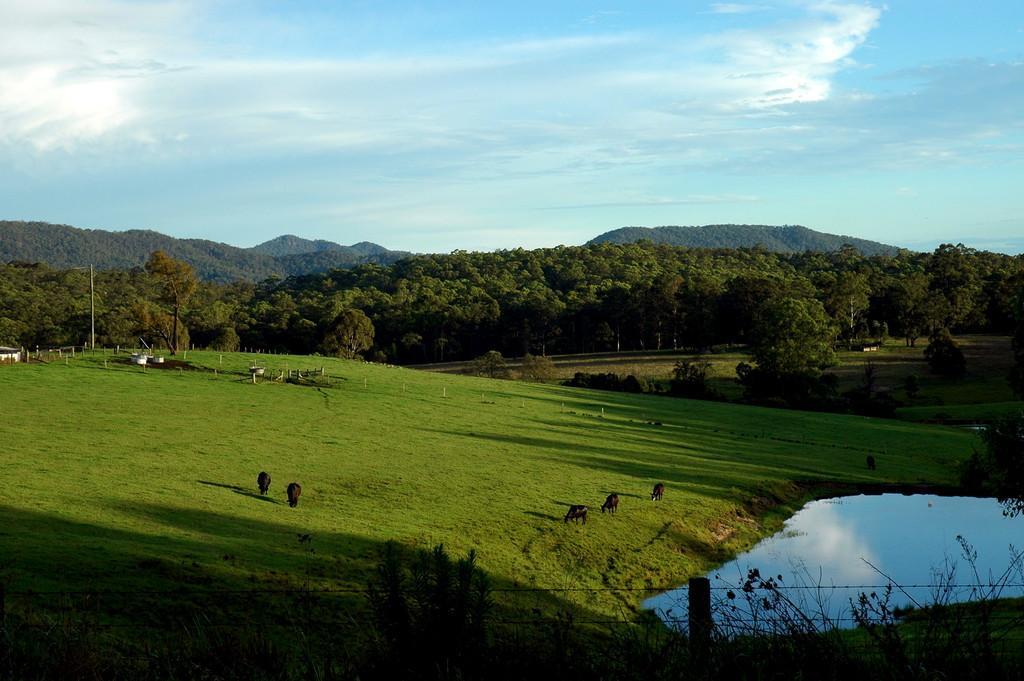Can you describe this image briefly? In this image there is grass on a hill. There are animals standing on the hill. In the background there are trees. At the top there is the sky. To the left there is a pole in the image. To the right there is the water. At the bottom there is a fencing. There are plants near to the fencing. 